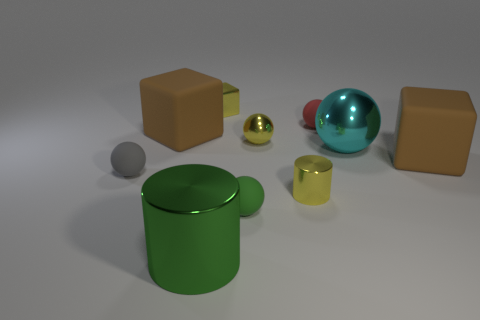What number of matte blocks are to the left of the large metal thing that is behind the gray rubber object?
Your answer should be very brief. 1. Are there any small yellow objects of the same shape as the tiny green object?
Provide a short and direct response. Yes. Does the big metallic object that is to the right of the red object have the same shape as the big brown matte thing in front of the big metallic ball?
Make the answer very short. No. How many things are either big cyan spheres or large objects?
Make the answer very short. 4. What is the size of the red object that is the same shape as the cyan metallic object?
Your answer should be very brief. Small. Is the number of shiny things in front of the small block greater than the number of green spheres?
Ensure brevity in your answer.  Yes. Is the material of the yellow sphere the same as the large sphere?
Offer a very short reply. Yes. What number of things are either rubber blocks in front of the big ball or green objects that are on the right side of the tiny shiny block?
Offer a terse response. 2. What is the color of the big shiny object that is the same shape as the tiny gray object?
Ensure brevity in your answer.  Cyan. What number of other tiny cylinders are the same color as the small metal cylinder?
Your response must be concise. 0. 